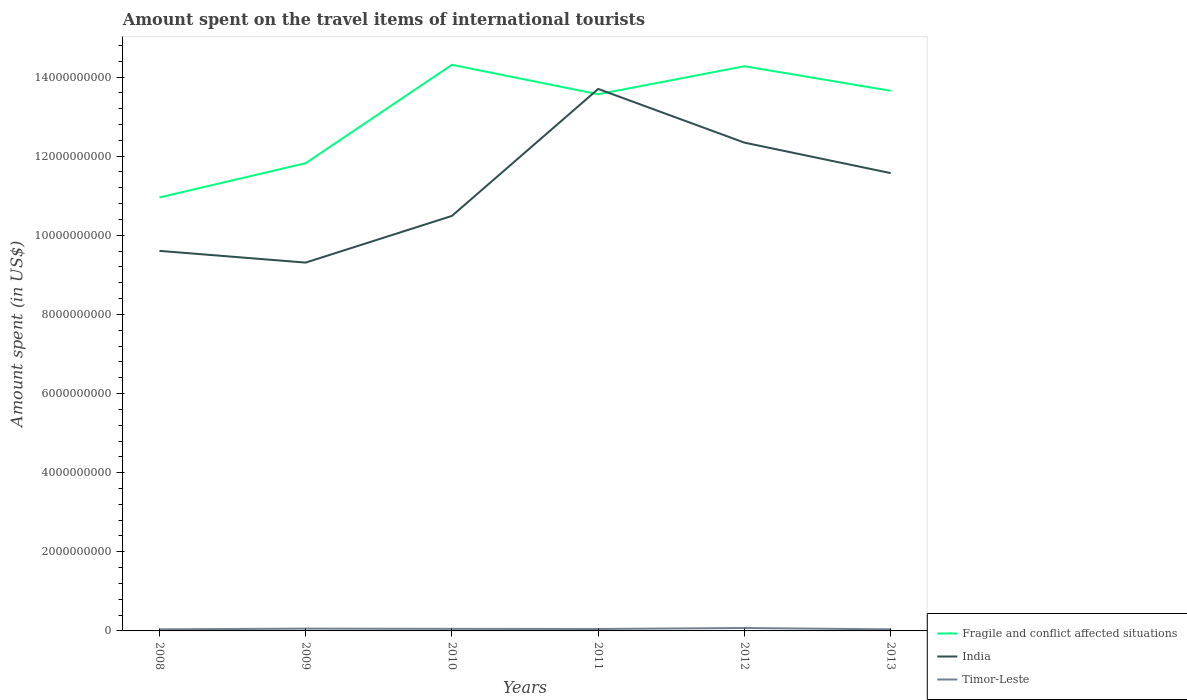How many different coloured lines are there?
Offer a very short reply. 3. Does the line corresponding to Timor-Leste intersect with the line corresponding to Fragile and conflict affected situations?
Your answer should be compact. No. Is the number of lines equal to the number of legend labels?
Your answer should be compact. Yes. Across all years, what is the maximum amount spent on the travel items of international tourists in Timor-Leste?
Make the answer very short. 4.00e+07. In which year was the amount spent on the travel items of international tourists in Fragile and conflict affected situations maximum?
Offer a terse response. 2008. What is the total amount spent on the travel items of international tourists in India in the graph?
Provide a succinct answer. -2.74e+09. What is the difference between the highest and the second highest amount spent on the travel items of international tourists in Timor-Leste?
Your answer should be very brief. 3.30e+07. What is the difference between the highest and the lowest amount spent on the travel items of international tourists in India?
Offer a terse response. 3. How many lines are there?
Keep it short and to the point. 3. What is the difference between two consecutive major ticks on the Y-axis?
Your answer should be compact. 2.00e+09. Are the values on the major ticks of Y-axis written in scientific E-notation?
Ensure brevity in your answer.  No. Does the graph contain any zero values?
Make the answer very short. No. Does the graph contain grids?
Make the answer very short. No. How many legend labels are there?
Your answer should be compact. 3. How are the legend labels stacked?
Your response must be concise. Vertical. What is the title of the graph?
Provide a succinct answer. Amount spent on the travel items of international tourists. Does "Seychelles" appear as one of the legend labels in the graph?
Your answer should be very brief. No. What is the label or title of the X-axis?
Provide a succinct answer. Years. What is the label or title of the Y-axis?
Make the answer very short. Amount spent (in US$). What is the Amount spent (in US$) of Fragile and conflict affected situations in 2008?
Make the answer very short. 1.10e+1. What is the Amount spent (in US$) of India in 2008?
Your response must be concise. 9.61e+09. What is the Amount spent (in US$) in Timor-Leste in 2008?
Give a very brief answer. 4.00e+07. What is the Amount spent (in US$) in Fragile and conflict affected situations in 2009?
Ensure brevity in your answer.  1.18e+1. What is the Amount spent (in US$) in India in 2009?
Provide a short and direct response. 9.31e+09. What is the Amount spent (in US$) of Timor-Leste in 2009?
Your answer should be compact. 5.80e+07. What is the Amount spent (in US$) in Fragile and conflict affected situations in 2010?
Provide a short and direct response. 1.43e+1. What is the Amount spent (in US$) in India in 2010?
Ensure brevity in your answer.  1.05e+1. What is the Amount spent (in US$) of Timor-Leste in 2010?
Offer a very short reply. 5.20e+07. What is the Amount spent (in US$) of Fragile and conflict affected situations in 2011?
Provide a succinct answer. 1.36e+1. What is the Amount spent (in US$) of India in 2011?
Provide a short and direct response. 1.37e+1. What is the Amount spent (in US$) of Timor-Leste in 2011?
Make the answer very short. 4.90e+07. What is the Amount spent (in US$) in Fragile and conflict affected situations in 2012?
Provide a succinct answer. 1.43e+1. What is the Amount spent (in US$) of India in 2012?
Offer a very short reply. 1.23e+1. What is the Amount spent (in US$) of Timor-Leste in 2012?
Your answer should be very brief. 7.30e+07. What is the Amount spent (in US$) of Fragile and conflict affected situations in 2013?
Your response must be concise. 1.37e+1. What is the Amount spent (in US$) of India in 2013?
Provide a succinct answer. 1.16e+1. What is the Amount spent (in US$) of Timor-Leste in 2013?
Ensure brevity in your answer.  4.00e+07. Across all years, what is the maximum Amount spent (in US$) in Fragile and conflict affected situations?
Offer a terse response. 1.43e+1. Across all years, what is the maximum Amount spent (in US$) of India?
Keep it short and to the point. 1.37e+1. Across all years, what is the maximum Amount spent (in US$) in Timor-Leste?
Your answer should be compact. 7.30e+07. Across all years, what is the minimum Amount spent (in US$) in Fragile and conflict affected situations?
Keep it short and to the point. 1.10e+1. Across all years, what is the minimum Amount spent (in US$) in India?
Provide a short and direct response. 9.31e+09. Across all years, what is the minimum Amount spent (in US$) in Timor-Leste?
Offer a terse response. 4.00e+07. What is the total Amount spent (in US$) in Fragile and conflict affected situations in the graph?
Your answer should be very brief. 7.86e+1. What is the total Amount spent (in US$) of India in the graph?
Provide a succinct answer. 6.70e+1. What is the total Amount spent (in US$) in Timor-Leste in the graph?
Your answer should be compact. 3.12e+08. What is the difference between the Amount spent (in US$) in Fragile and conflict affected situations in 2008 and that in 2009?
Your answer should be compact. -8.66e+08. What is the difference between the Amount spent (in US$) of India in 2008 and that in 2009?
Ensure brevity in your answer.  2.96e+08. What is the difference between the Amount spent (in US$) of Timor-Leste in 2008 and that in 2009?
Offer a terse response. -1.80e+07. What is the difference between the Amount spent (in US$) of Fragile and conflict affected situations in 2008 and that in 2010?
Give a very brief answer. -3.35e+09. What is the difference between the Amount spent (in US$) in India in 2008 and that in 2010?
Make the answer very short. -8.84e+08. What is the difference between the Amount spent (in US$) in Timor-Leste in 2008 and that in 2010?
Your answer should be compact. -1.20e+07. What is the difference between the Amount spent (in US$) in Fragile and conflict affected situations in 2008 and that in 2011?
Offer a terse response. -2.61e+09. What is the difference between the Amount spent (in US$) in India in 2008 and that in 2011?
Your answer should be very brief. -4.09e+09. What is the difference between the Amount spent (in US$) of Timor-Leste in 2008 and that in 2011?
Your response must be concise. -9.00e+06. What is the difference between the Amount spent (in US$) of Fragile and conflict affected situations in 2008 and that in 2012?
Your answer should be very brief. -3.32e+09. What is the difference between the Amount spent (in US$) of India in 2008 and that in 2012?
Make the answer very short. -2.74e+09. What is the difference between the Amount spent (in US$) of Timor-Leste in 2008 and that in 2012?
Your answer should be very brief. -3.30e+07. What is the difference between the Amount spent (in US$) of Fragile and conflict affected situations in 2008 and that in 2013?
Provide a succinct answer. -2.70e+09. What is the difference between the Amount spent (in US$) of India in 2008 and that in 2013?
Provide a succinct answer. -1.96e+09. What is the difference between the Amount spent (in US$) in Timor-Leste in 2008 and that in 2013?
Ensure brevity in your answer.  0. What is the difference between the Amount spent (in US$) of Fragile and conflict affected situations in 2009 and that in 2010?
Your answer should be very brief. -2.49e+09. What is the difference between the Amount spent (in US$) in India in 2009 and that in 2010?
Your response must be concise. -1.18e+09. What is the difference between the Amount spent (in US$) in Fragile and conflict affected situations in 2009 and that in 2011?
Keep it short and to the point. -1.74e+09. What is the difference between the Amount spent (in US$) of India in 2009 and that in 2011?
Offer a very short reply. -4.39e+09. What is the difference between the Amount spent (in US$) of Timor-Leste in 2009 and that in 2011?
Keep it short and to the point. 9.00e+06. What is the difference between the Amount spent (in US$) of Fragile and conflict affected situations in 2009 and that in 2012?
Offer a terse response. -2.45e+09. What is the difference between the Amount spent (in US$) in India in 2009 and that in 2012?
Give a very brief answer. -3.03e+09. What is the difference between the Amount spent (in US$) in Timor-Leste in 2009 and that in 2012?
Provide a short and direct response. -1.50e+07. What is the difference between the Amount spent (in US$) in Fragile and conflict affected situations in 2009 and that in 2013?
Offer a very short reply. -1.83e+09. What is the difference between the Amount spent (in US$) in India in 2009 and that in 2013?
Give a very brief answer. -2.26e+09. What is the difference between the Amount spent (in US$) in Timor-Leste in 2009 and that in 2013?
Make the answer very short. 1.80e+07. What is the difference between the Amount spent (in US$) of Fragile and conflict affected situations in 2010 and that in 2011?
Give a very brief answer. 7.44e+08. What is the difference between the Amount spent (in US$) in India in 2010 and that in 2011?
Ensure brevity in your answer.  -3.21e+09. What is the difference between the Amount spent (in US$) in Fragile and conflict affected situations in 2010 and that in 2012?
Your response must be concise. 3.63e+07. What is the difference between the Amount spent (in US$) in India in 2010 and that in 2012?
Keep it short and to the point. -1.85e+09. What is the difference between the Amount spent (in US$) of Timor-Leste in 2010 and that in 2012?
Offer a terse response. -2.10e+07. What is the difference between the Amount spent (in US$) in Fragile and conflict affected situations in 2010 and that in 2013?
Your answer should be very brief. 6.57e+08. What is the difference between the Amount spent (in US$) of India in 2010 and that in 2013?
Provide a short and direct response. -1.08e+09. What is the difference between the Amount spent (in US$) of Fragile and conflict affected situations in 2011 and that in 2012?
Provide a succinct answer. -7.08e+08. What is the difference between the Amount spent (in US$) in India in 2011 and that in 2012?
Provide a short and direct response. 1.36e+09. What is the difference between the Amount spent (in US$) of Timor-Leste in 2011 and that in 2012?
Ensure brevity in your answer.  -2.40e+07. What is the difference between the Amount spent (in US$) in Fragile and conflict affected situations in 2011 and that in 2013?
Provide a succinct answer. -8.71e+07. What is the difference between the Amount spent (in US$) of India in 2011 and that in 2013?
Your response must be concise. 2.13e+09. What is the difference between the Amount spent (in US$) in Timor-Leste in 2011 and that in 2013?
Provide a succinct answer. 9.00e+06. What is the difference between the Amount spent (in US$) of Fragile and conflict affected situations in 2012 and that in 2013?
Your answer should be compact. 6.21e+08. What is the difference between the Amount spent (in US$) of India in 2012 and that in 2013?
Your response must be concise. 7.71e+08. What is the difference between the Amount spent (in US$) of Timor-Leste in 2012 and that in 2013?
Give a very brief answer. 3.30e+07. What is the difference between the Amount spent (in US$) in Fragile and conflict affected situations in 2008 and the Amount spent (in US$) in India in 2009?
Your answer should be very brief. 1.65e+09. What is the difference between the Amount spent (in US$) of Fragile and conflict affected situations in 2008 and the Amount spent (in US$) of Timor-Leste in 2009?
Offer a very short reply. 1.09e+1. What is the difference between the Amount spent (in US$) of India in 2008 and the Amount spent (in US$) of Timor-Leste in 2009?
Offer a very short reply. 9.55e+09. What is the difference between the Amount spent (in US$) of Fragile and conflict affected situations in 2008 and the Amount spent (in US$) of India in 2010?
Give a very brief answer. 4.66e+08. What is the difference between the Amount spent (in US$) of Fragile and conflict affected situations in 2008 and the Amount spent (in US$) of Timor-Leste in 2010?
Offer a very short reply. 1.09e+1. What is the difference between the Amount spent (in US$) of India in 2008 and the Amount spent (in US$) of Timor-Leste in 2010?
Ensure brevity in your answer.  9.55e+09. What is the difference between the Amount spent (in US$) of Fragile and conflict affected situations in 2008 and the Amount spent (in US$) of India in 2011?
Offer a terse response. -2.74e+09. What is the difference between the Amount spent (in US$) of Fragile and conflict affected situations in 2008 and the Amount spent (in US$) of Timor-Leste in 2011?
Your response must be concise. 1.09e+1. What is the difference between the Amount spent (in US$) in India in 2008 and the Amount spent (in US$) in Timor-Leste in 2011?
Offer a very short reply. 9.56e+09. What is the difference between the Amount spent (in US$) in Fragile and conflict affected situations in 2008 and the Amount spent (in US$) in India in 2012?
Offer a terse response. -1.39e+09. What is the difference between the Amount spent (in US$) in Fragile and conflict affected situations in 2008 and the Amount spent (in US$) in Timor-Leste in 2012?
Provide a short and direct response. 1.09e+1. What is the difference between the Amount spent (in US$) of India in 2008 and the Amount spent (in US$) of Timor-Leste in 2012?
Ensure brevity in your answer.  9.53e+09. What is the difference between the Amount spent (in US$) of Fragile and conflict affected situations in 2008 and the Amount spent (in US$) of India in 2013?
Keep it short and to the point. -6.15e+08. What is the difference between the Amount spent (in US$) in Fragile and conflict affected situations in 2008 and the Amount spent (in US$) in Timor-Leste in 2013?
Give a very brief answer. 1.09e+1. What is the difference between the Amount spent (in US$) in India in 2008 and the Amount spent (in US$) in Timor-Leste in 2013?
Offer a terse response. 9.57e+09. What is the difference between the Amount spent (in US$) of Fragile and conflict affected situations in 2009 and the Amount spent (in US$) of India in 2010?
Offer a terse response. 1.33e+09. What is the difference between the Amount spent (in US$) of Fragile and conflict affected situations in 2009 and the Amount spent (in US$) of Timor-Leste in 2010?
Provide a succinct answer. 1.18e+1. What is the difference between the Amount spent (in US$) of India in 2009 and the Amount spent (in US$) of Timor-Leste in 2010?
Your response must be concise. 9.26e+09. What is the difference between the Amount spent (in US$) of Fragile and conflict affected situations in 2009 and the Amount spent (in US$) of India in 2011?
Give a very brief answer. -1.88e+09. What is the difference between the Amount spent (in US$) in Fragile and conflict affected situations in 2009 and the Amount spent (in US$) in Timor-Leste in 2011?
Give a very brief answer. 1.18e+1. What is the difference between the Amount spent (in US$) in India in 2009 and the Amount spent (in US$) in Timor-Leste in 2011?
Your answer should be compact. 9.26e+09. What is the difference between the Amount spent (in US$) of Fragile and conflict affected situations in 2009 and the Amount spent (in US$) of India in 2012?
Ensure brevity in your answer.  -5.20e+08. What is the difference between the Amount spent (in US$) of Fragile and conflict affected situations in 2009 and the Amount spent (in US$) of Timor-Leste in 2012?
Ensure brevity in your answer.  1.17e+1. What is the difference between the Amount spent (in US$) in India in 2009 and the Amount spent (in US$) in Timor-Leste in 2012?
Ensure brevity in your answer.  9.24e+09. What is the difference between the Amount spent (in US$) in Fragile and conflict affected situations in 2009 and the Amount spent (in US$) in India in 2013?
Your answer should be compact. 2.51e+08. What is the difference between the Amount spent (in US$) in Fragile and conflict affected situations in 2009 and the Amount spent (in US$) in Timor-Leste in 2013?
Offer a terse response. 1.18e+1. What is the difference between the Amount spent (in US$) of India in 2009 and the Amount spent (in US$) of Timor-Leste in 2013?
Offer a very short reply. 9.27e+09. What is the difference between the Amount spent (in US$) in Fragile and conflict affected situations in 2010 and the Amount spent (in US$) in India in 2011?
Provide a succinct answer. 6.10e+08. What is the difference between the Amount spent (in US$) of Fragile and conflict affected situations in 2010 and the Amount spent (in US$) of Timor-Leste in 2011?
Provide a succinct answer. 1.43e+1. What is the difference between the Amount spent (in US$) in India in 2010 and the Amount spent (in US$) in Timor-Leste in 2011?
Ensure brevity in your answer.  1.04e+1. What is the difference between the Amount spent (in US$) of Fragile and conflict affected situations in 2010 and the Amount spent (in US$) of India in 2012?
Provide a short and direct response. 1.97e+09. What is the difference between the Amount spent (in US$) of Fragile and conflict affected situations in 2010 and the Amount spent (in US$) of Timor-Leste in 2012?
Offer a very short reply. 1.42e+1. What is the difference between the Amount spent (in US$) of India in 2010 and the Amount spent (in US$) of Timor-Leste in 2012?
Your answer should be very brief. 1.04e+1. What is the difference between the Amount spent (in US$) in Fragile and conflict affected situations in 2010 and the Amount spent (in US$) in India in 2013?
Your response must be concise. 2.74e+09. What is the difference between the Amount spent (in US$) in Fragile and conflict affected situations in 2010 and the Amount spent (in US$) in Timor-Leste in 2013?
Your answer should be compact. 1.43e+1. What is the difference between the Amount spent (in US$) in India in 2010 and the Amount spent (in US$) in Timor-Leste in 2013?
Offer a very short reply. 1.04e+1. What is the difference between the Amount spent (in US$) of Fragile and conflict affected situations in 2011 and the Amount spent (in US$) of India in 2012?
Your response must be concise. 1.22e+09. What is the difference between the Amount spent (in US$) of Fragile and conflict affected situations in 2011 and the Amount spent (in US$) of Timor-Leste in 2012?
Your answer should be compact. 1.35e+1. What is the difference between the Amount spent (in US$) of India in 2011 and the Amount spent (in US$) of Timor-Leste in 2012?
Ensure brevity in your answer.  1.36e+1. What is the difference between the Amount spent (in US$) of Fragile and conflict affected situations in 2011 and the Amount spent (in US$) of India in 2013?
Offer a very short reply. 1.99e+09. What is the difference between the Amount spent (in US$) in Fragile and conflict affected situations in 2011 and the Amount spent (in US$) in Timor-Leste in 2013?
Your answer should be very brief. 1.35e+1. What is the difference between the Amount spent (in US$) of India in 2011 and the Amount spent (in US$) of Timor-Leste in 2013?
Your response must be concise. 1.37e+1. What is the difference between the Amount spent (in US$) in Fragile and conflict affected situations in 2012 and the Amount spent (in US$) in India in 2013?
Your answer should be very brief. 2.70e+09. What is the difference between the Amount spent (in US$) in Fragile and conflict affected situations in 2012 and the Amount spent (in US$) in Timor-Leste in 2013?
Offer a terse response. 1.42e+1. What is the difference between the Amount spent (in US$) of India in 2012 and the Amount spent (in US$) of Timor-Leste in 2013?
Your answer should be very brief. 1.23e+1. What is the average Amount spent (in US$) in Fragile and conflict affected situations per year?
Ensure brevity in your answer.  1.31e+1. What is the average Amount spent (in US$) of India per year?
Provide a short and direct response. 1.12e+1. What is the average Amount spent (in US$) of Timor-Leste per year?
Your response must be concise. 5.20e+07. In the year 2008, what is the difference between the Amount spent (in US$) in Fragile and conflict affected situations and Amount spent (in US$) in India?
Keep it short and to the point. 1.35e+09. In the year 2008, what is the difference between the Amount spent (in US$) of Fragile and conflict affected situations and Amount spent (in US$) of Timor-Leste?
Keep it short and to the point. 1.09e+1. In the year 2008, what is the difference between the Amount spent (in US$) in India and Amount spent (in US$) in Timor-Leste?
Give a very brief answer. 9.57e+09. In the year 2009, what is the difference between the Amount spent (in US$) of Fragile and conflict affected situations and Amount spent (in US$) of India?
Keep it short and to the point. 2.51e+09. In the year 2009, what is the difference between the Amount spent (in US$) of Fragile and conflict affected situations and Amount spent (in US$) of Timor-Leste?
Give a very brief answer. 1.18e+1. In the year 2009, what is the difference between the Amount spent (in US$) of India and Amount spent (in US$) of Timor-Leste?
Your response must be concise. 9.25e+09. In the year 2010, what is the difference between the Amount spent (in US$) in Fragile and conflict affected situations and Amount spent (in US$) in India?
Make the answer very short. 3.82e+09. In the year 2010, what is the difference between the Amount spent (in US$) in Fragile and conflict affected situations and Amount spent (in US$) in Timor-Leste?
Your answer should be compact. 1.43e+1. In the year 2010, what is the difference between the Amount spent (in US$) in India and Amount spent (in US$) in Timor-Leste?
Keep it short and to the point. 1.04e+1. In the year 2011, what is the difference between the Amount spent (in US$) in Fragile and conflict affected situations and Amount spent (in US$) in India?
Your answer should be very brief. -1.34e+08. In the year 2011, what is the difference between the Amount spent (in US$) in Fragile and conflict affected situations and Amount spent (in US$) in Timor-Leste?
Your answer should be very brief. 1.35e+1. In the year 2011, what is the difference between the Amount spent (in US$) in India and Amount spent (in US$) in Timor-Leste?
Offer a terse response. 1.36e+1. In the year 2012, what is the difference between the Amount spent (in US$) in Fragile and conflict affected situations and Amount spent (in US$) in India?
Your answer should be very brief. 1.93e+09. In the year 2012, what is the difference between the Amount spent (in US$) of Fragile and conflict affected situations and Amount spent (in US$) of Timor-Leste?
Offer a very short reply. 1.42e+1. In the year 2012, what is the difference between the Amount spent (in US$) of India and Amount spent (in US$) of Timor-Leste?
Ensure brevity in your answer.  1.23e+1. In the year 2013, what is the difference between the Amount spent (in US$) of Fragile and conflict affected situations and Amount spent (in US$) of India?
Provide a succinct answer. 2.08e+09. In the year 2013, what is the difference between the Amount spent (in US$) of Fragile and conflict affected situations and Amount spent (in US$) of Timor-Leste?
Make the answer very short. 1.36e+1. In the year 2013, what is the difference between the Amount spent (in US$) of India and Amount spent (in US$) of Timor-Leste?
Keep it short and to the point. 1.15e+1. What is the ratio of the Amount spent (in US$) in Fragile and conflict affected situations in 2008 to that in 2009?
Ensure brevity in your answer.  0.93. What is the ratio of the Amount spent (in US$) in India in 2008 to that in 2009?
Your answer should be very brief. 1.03. What is the ratio of the Amount spent (in US$) in Timor-Leste in 2008 to that in 2009?
Provide a succinct answer. 0.69. What is the ratio of the Amount spent (in US$) of Fragile and conflict affected situations in 2008 to that in 2010?
Your response must be concise. 0.77. What is the ratio of the Amount spent (in US$) in India in 2008 to that in 2010?
Your answer should be compact. 0.92. What is the ratio of the Amount spent (in US$) of Timor-Leste in 2008 to that in 2010?
Offer a terse response. 0.77. What is the ratio of the Amount spent (in US$) in Fragile and conflict affected situations in 2008 to that in 2011?
Your answer should be compact. 0.81. What is the ratio of the Amount spent (in US$) of India in 2008 to that in 2011?
Ensure brevity in your answer.  0.7. What is the ratio of the Amount spent (in US$) of Timor-Leste in 2008 to that in 2011?
Provide a short and direct response. 0.82. What is the ratio of the Amount spent (in US$) in Fragile and conflict affected situations in 2008 to that in 2012?
Your answer should be compact. 0.77. What is the ratio of the Amount spent (in US$) of India in 2008 to that in 2012?
Provide a short and direct response. 0.78. What is the ratio of the Amount spent (in US$) of Timor-Leste in 2008 to that in 2012?
Offer a very short reply. 0.55. What is the ratio of the Amount spent (in US$) of Fragile and conflict affected situations in 2008 to that in 2013?
Ensure brevity in your answer.  0.8. What is the ratio of the Amount spent (in US$) in India in 2008 to that in 2013?
Provide a short and direct response. 0.83. What is the ratio of the Amount spent (in US$) of Fragile and conflict affected situations in 2009 to that in 2010?
Provide a short and direct response. 0.83. What is the ratio of the Amount spent (in US$) in India in 2009 to that in 2010?
Ensure brevity in your answer.  0.89. What is the ratio of the Amount spent (in US$) of Timor-Leste in 2009 to that in 2010?
Offer a terse response. 1.12. What is the ratio of the Amount spent (in US$) of Fragile and conflict affected situations in 2009 to that in 2011?
Your answer should be compact. 0.87. What is the ratio of the Amount spent (in US$) of India in 2009 to that in 2011?
Ensure brevity in your answer.  0.68. What is the ratio of the Amount spent (in US$) in Timor-Leste in 2009 to that in 2011?
Give a very brief answer. 1.18. What is the ratio of the Amount spent (in US$) of Fragile and conflict affected situations in 2009 to that in 2012?
Give a very brief answer. 0.83. What is the ratio of the Amount spent (in US$) of India in 2009 to that in 2012?
Your answer should be very brief. 0.75. What is the ratio of the Amount spent (in US$) of Timor-Leste in 2009 to that in 2012?
Make the answer very short. 0.79. What is the ratio of the Amount spent (in US$) in Fragile and conflict affected situations in 2009 to that in 2013?
Keep it short and to the point. 0.87. What is the ratio of the Amount spent (in US$) of India in 2009 to that in 2013?
Give a very brief answer. 0.8. What is the ratio of the Amount spent (in US$) of Timor-Leste in 2009 to that in 2013?
Ensure brevity in your answer.  1.45. What is the ratio of the Amount spent (in US$) of Fragile and conflict affected situations in 2010 to that in 2011?
Provide a short and direct response. 1.05. What is the ratio of the Amount spent (in US$) in India in 2010 to that in 2011?
Provide a short and direct response. 0.77. What is the ratio of the Amount spent (in US$) in Timor-Leste in 2010 to that in 2011?
Provide a succinct answer. 1.06. What is the ratio of the Amount spent (in US$) in Fragile and conflict affected situations in 2010 to that in 2012?
Offer a terse response. 1. What is the ratio of the Amount spent (in US$) in India in 2010 to that in 2012?
Ensure brevity in your answer.  0.85. What is the ratio of the Amount spent (in US$) of Timor-Leste in 2010 to that in 2012?
Offer a very short reply. 0.71. What is the ratio of the Amount spent (in US$) of Fragile and conflict affected situations in 2010 to that in 2013?
Offer a terse response. 1.05. What is the ratio of the Amount spent (in US$) of India in 2010 to that in 2013?
Provide a short and direct response. 0.91. What is the ratio of the Amount spent (in US$) of Timor-Leste in 2010 to that in 2013?
Provide a succinct answer. 1.3. What is the ratio of the Amount spent (in US$) in Fragile and conflict affected situations in 2011 to that in 2012?
Provide a succinct answer. 0.95. What is the ratio of the Amount spent (in US$) in India in 2011 to that in 2012?
Offer a very short reply. 1.11. What is the ratio of the Amount spent (in US$) of Timor-Leste in 2011 to that in 2012?
Keep it short and to the point. 0.67. What is the ratio of the Amount spent (in US$) in India in 2011 to that in 2013?
Your answer should be very brief. 1.18. What is the ratio of the Amount spent (in US$) in Timor-Leste in 2011 to that in 2013?
Provide a short and direct response. 1.23. What is the ratio of the Amount spent (in US$) in Fragile and conflict affected situations in 2012 to that in 2013?
Your answer should be very brief. 1.05. What is the ratio of the Amount spent (in US$) in India in 2012 to that in 2013?
Offer a terse response. 1.07. What is the ratio of the Amount spent (in US$) in Timor-Leste in 2012 to that in 2013?
Your response must be concise. 1.82. What is the difference between the highest and the second highest Amount spent (in US$) in Fragile and conflict affected situations?
Provide a succinct answer. 3.63e+07. What is the difference between the highest and the second highest Amount spent (in US$) in India?
Keep it short and to the point. 1.36e+09. What is the difference between the highest and the second highest Amount spent (in US$) in Timor-Leste?
Offer a very short reply. 1.50e+07. What is the difference between the highest and the lowest Amount spent (in US$) of Fragile and conflict affected situations?
Provide a succinct answer. 3.35e+09. What is the difference between the highest and the lowest Amount spent (in US$) in India?
Your response must be concise. 4.39e+09. What is the difference between the highest and the lowest Amount spent (in US$) of Timor-Leste?
Your answer should be very brief. 3.30e+07. 